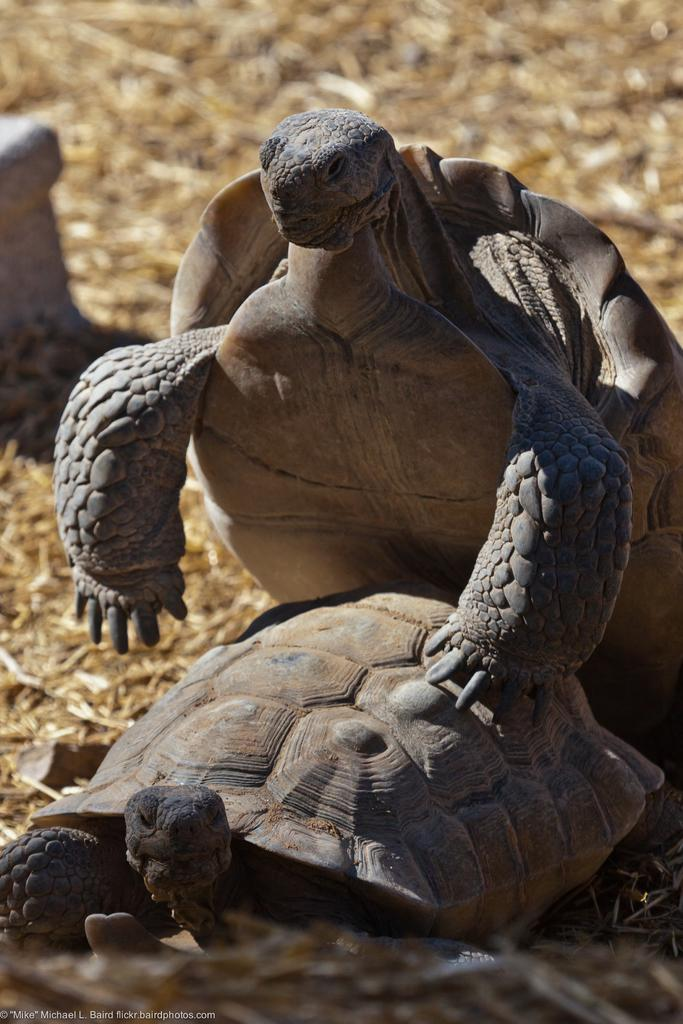What type of animals are present in the image? There are tortoises in the image. Where are the tortoises located? The tortoises are on a land. What type of secretary desk can be seen in the image? There is no secretary desk present in the image; it features tortoises on a land. How many carts are visible in the image? There are no carts visible in the image; it features tortoises on a land. 